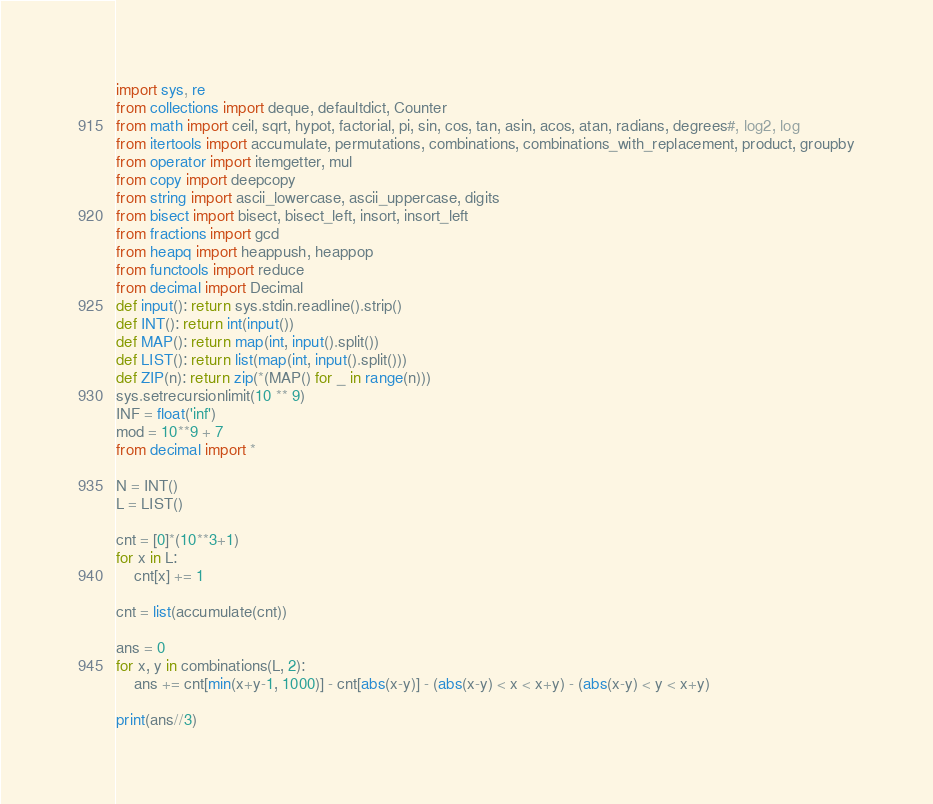<code> <loc_0><loc_0><loc_500><loc_500><_Python_>import sys, re
from collections import deque, defaultdict, Counter
from math import ceil, sqrt, hypot, factorial, pi, sin, cos, tan, asin, acos, atan, radians, degrees#, log2, log
from itertools import accumulate, permutations, combinations, combinations_with_replacement, product, groupby
from operator import itemgetter, mul
from copy import deepcopy
from string import ascii_lowercase, ascii_uppercase, digits
from bisect import bisect, bisect_left, insort, insort_left
from fractions import gcd
from heapq import heappush, heappop
from functools import reduce
from decimal import Decimal
def input(): return sys.stdin.readline().strip()
def INT(): return int(input())
def MAP(): return map(int, input().split())
def LIST(): return list(map(int, input().split()))
def ZIP(n): return zip(*(MAP() for _ in range(n)))
sys.setrecursionlimit(10 ** 9)
INF = float('inf')
mod = 10**9 + 7
from decimal import *

N = INT()
L = LIST()

cnt = [0]*(10**3+1)
for x in L:
	cnt[x] += 1

cnt = list(accumulate(cnt))

ans = 0
for x, y in combinations(L, 2):
	ans += cnt[min(x+y-1, 1000)] - cnt[abs(x-y)] - (abs(x-y) < x < x+y) - (abs(x-y) < y < x+y)

print(ans//3)</code> 